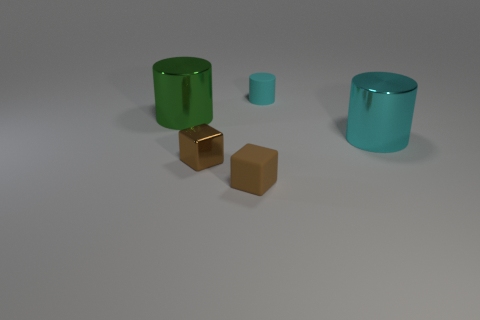Which objects in the image appear to have a reflective surface? The two cylindrical objects, as well as the two smaller cubes on the surface, demonstrate reflective properties suggesting they're likely made of a glossy material. 